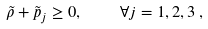<formula> <loc_0><loc_0><loc_500><loc_500>\tilde { \rho } + \tilde { p } _ { j } \geq 0 , \quad \forall j = 1 , 2 , 3 \, ,</formula> 